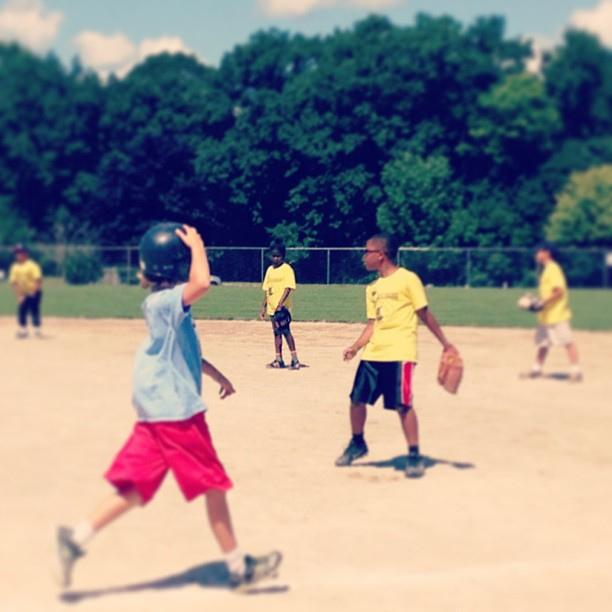What color are the shorts on the boy wearing a baseball helmet? red 